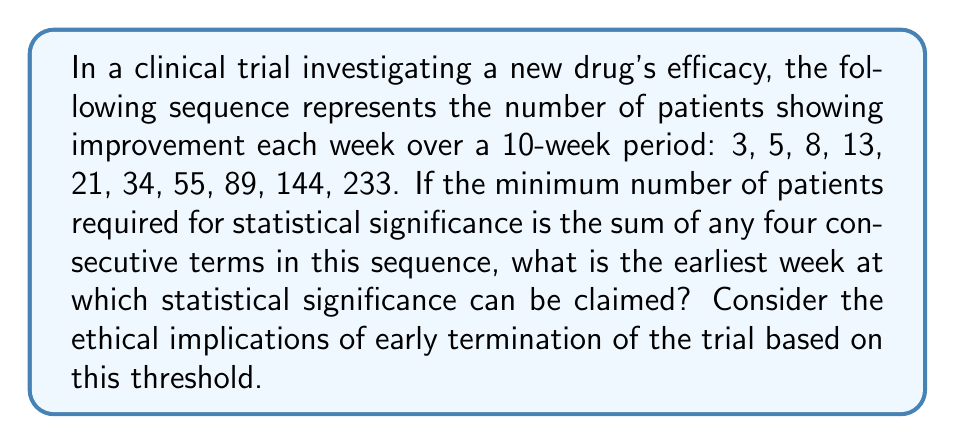Can you solve this math problem? To solve this problem, we need to follow these steps:

1) First, recognize that this is a Fibonacci sequence, where each term is the sum of the two preceding ones.

2) We need to find the sum of any four consecutive terms that first exceeds the threshold for statistical significance.

3) Let's calculate the sums of four consecutive terms:

   Week 1-4: $3 + 5 + 8 + 13 = 29$
   Week 2-5: $5 + 8 + 13 + 21 = 47$
   Week 3-6: $8 + 13 + 21 + 34 = 76$
   Week 4-7: $13 + 21 + 34 + 55 = 123$
   Week 5-8: $21 + 34 + 55 + 89 = 199$
   Week 6-9: $34 + 55 + 89 + 144 = 322$
   Week 7-10: $55 + 89 + 144 + 233 = 521$

4) The sum first exceeds the threshold in the period from Week 6-9, with a total of 322 patients showing improvement.

5) Since this sum includes data up to Week 9, statistical significance can be claimed at the end of Week 9.

From an ethical perspective, it's crucial to consider that while statistical significance may be achieved earlier, continuing the trial for its planned duration could provide more robust data on long-term effects and rare side effects. Early termination based solely on this threshold might compromise the comprehensive understanding of the drug's efficacy and safety profile.
Answer: Week 9 